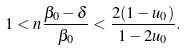<formula> <loc_0><loc_0><loc_500><loc_500>1 < n \frac { \beta _ { 0 } - \delta } { \beta _ { 0 } } < \frac { 2 ( 1 - u _ { 0 } ) } { 1 - 2 u _ { 0 } } .</formula> 